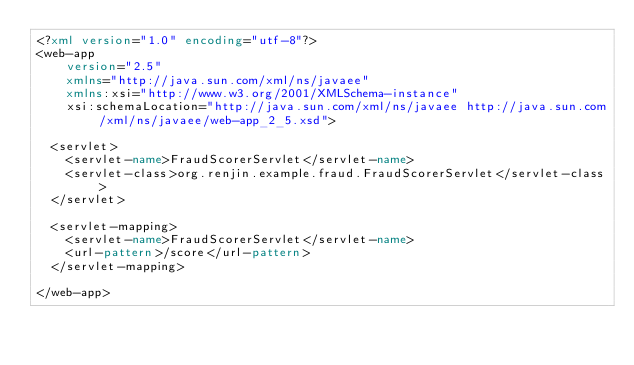<code> <loc_0><loc_0><loc_500><loc_500><_XML_><?xml version="1.0" encoding="utf-8"?>
<web-app
    version="2.5"
    xmlns="http://java.sun.com/xml/ns/javaee"
    xmlns:xsi="http://www.w3.org/2001/XMLSchema-instance"
    xsi:schemaLocation="http://java.sun.com/xml/ns/javaee http://java.sun.com/xml/ns/javaee/web-app_2_5.xsd">

  <servlet>
    <servlet-name>FraudScorerServlet</servlet-name>
    <servlet-class>org.renjin.example.fraud.FraudScorerServlet</servlet-class>
  </servlet>

  <servlet-mapping>
    <servlet-name>FraudScorerServlet</servlet-name>
    <url-pattern>/score</url-pattern>
  </servlet-mapping>

</web-app>
</code> 